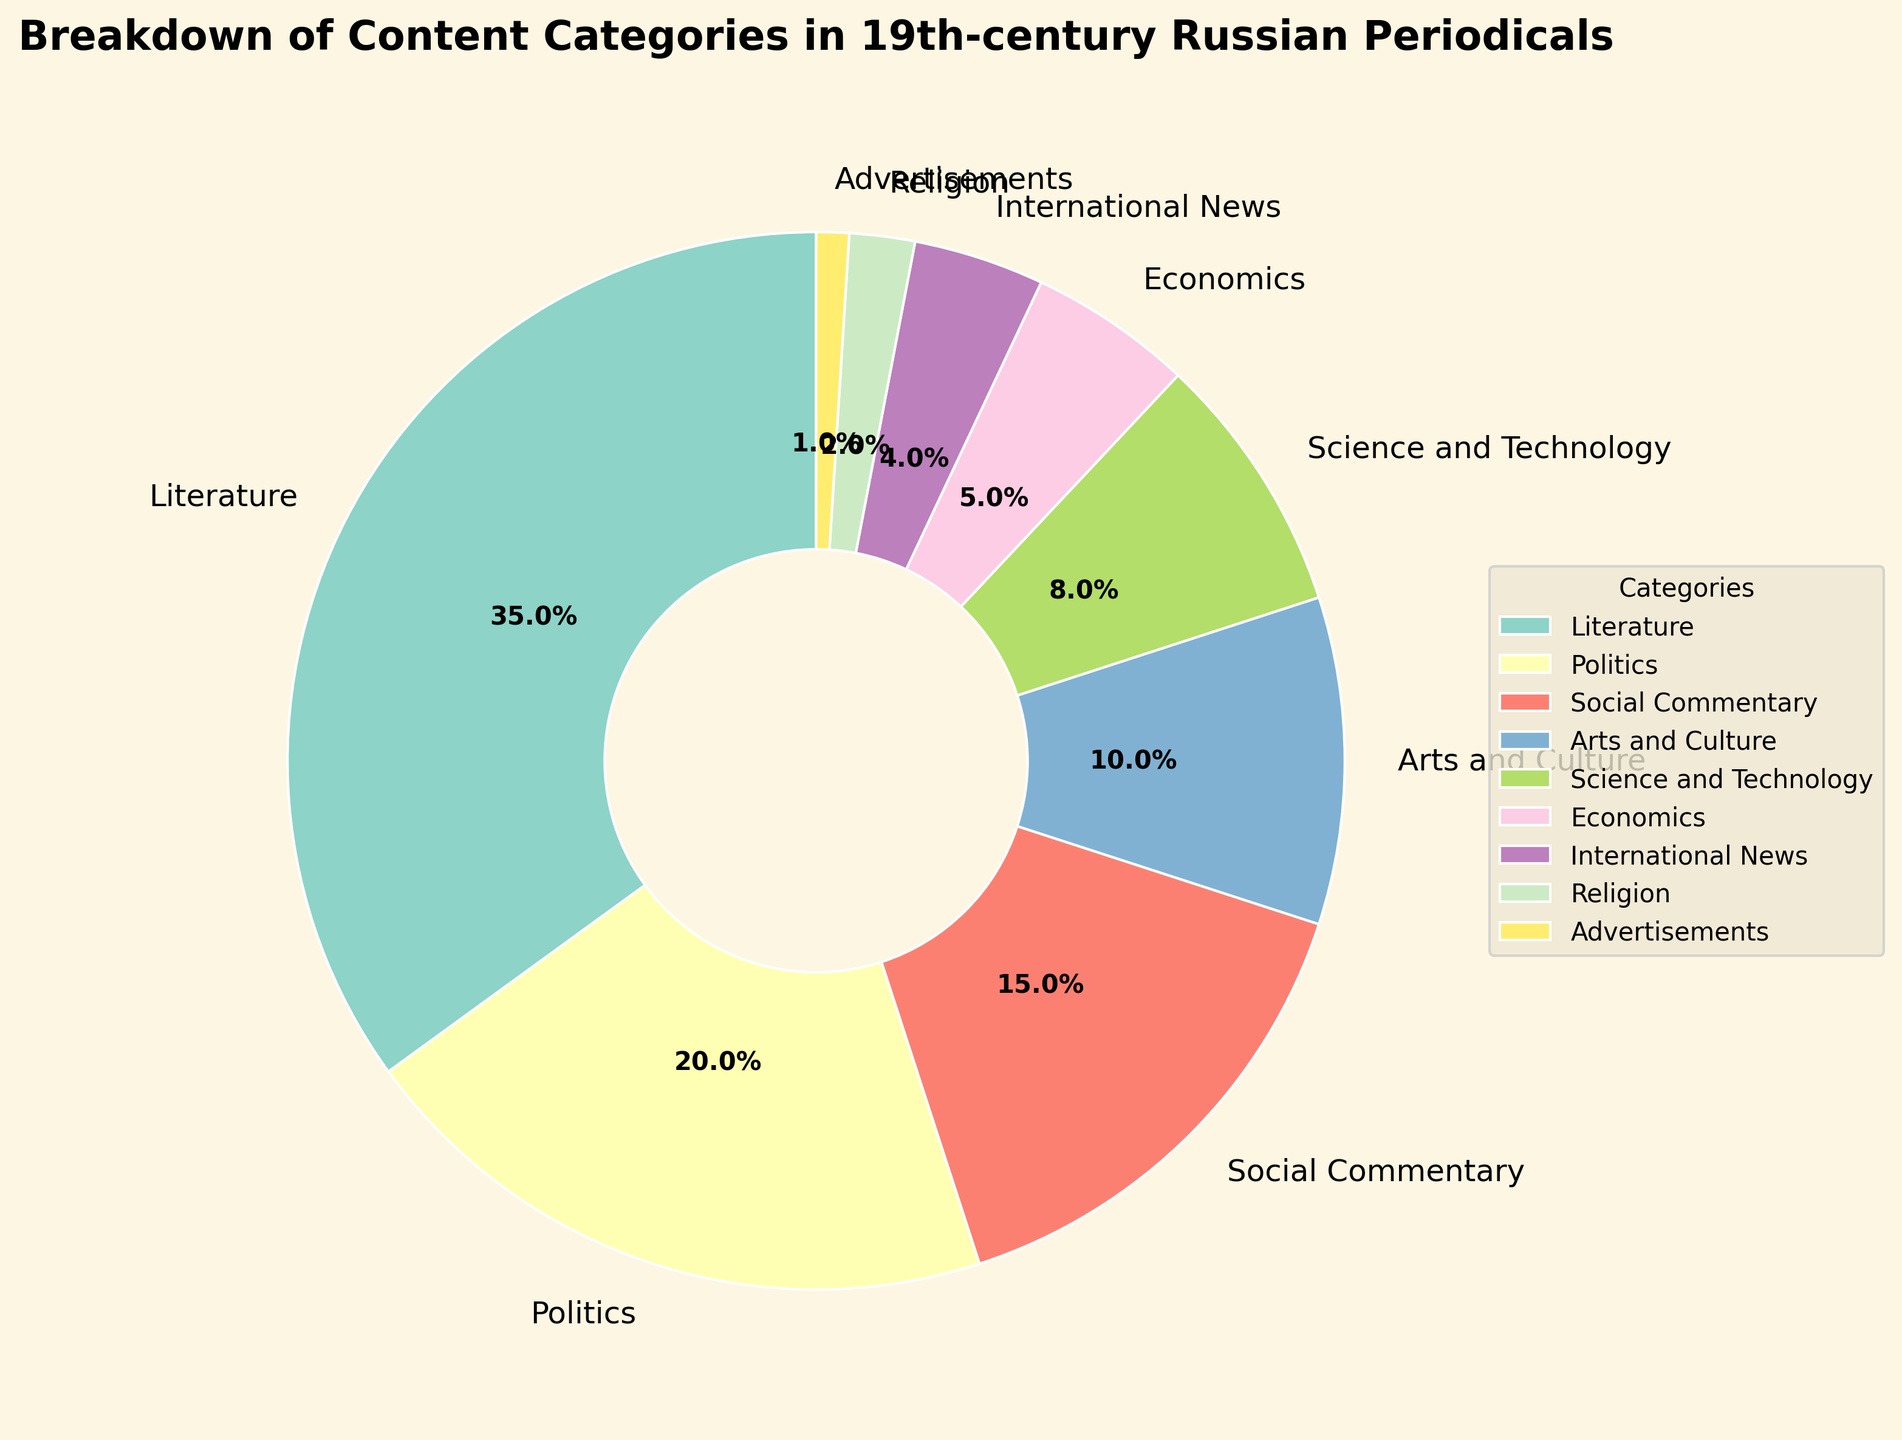Which content category occupies the largest percentage in 19th-century Russian periodicals? The figure shows a breakdown of content categories with their percentages. By checking which slice of the pie chart is largest, we find that Literature has the largest percentage at 35%.
Answer: Literature How much larger in percentage is the Literature category compared to the International News category? The percentage for Literature is 35%, and for International News, it is 4%. Subtracting the smaller percentage from the larger one (35% - 4% = 31%) shows that Literature is 31% larger than International News.
Answer: 31% What is the combined percentage of the Politics and Social Commentary categories? The figure shows Politics at 20% and Social Commentary at 15%. Adding these two percentages together (20% + 15%) gives the combined percentage of 35%.
Answer: 35% Which category has the smallest representation in the chart? By identifying the smallest slice, we can see that Advertisements have the smallest percentage at 1%.
Answer: Advertisements Is the percentage of Arts and Culture more than, less than, or equal to the combined percentage of Science and Technology and Religion? Arts and Culture is 10%. Science and Technology is 8%, and Religion is 2%. The combined percentage for Science and Technology and Religion is 10% (8% + 2%). Therefore, Arts and Culture is equal to the combined percentage of Science and Technology and Religion.
Answer: Equal Arrange the categories in decreasing order of their percentages. The percentages are given as follows: Literature (35%), Politics (20%), Social Commentary (15%), Arts and Culture (10%), Science and Technology (8%), Economics (5%), International News (4%), Religion (2%), Advertisements (1%). Arranging these in decreasing order: Literature, Politics, Social Commentary, Arts and Culture, Science and Technology, Economics, International News, Religion, Advertisements.
Answer: Literature, Politics, Social Commentary, Arts and Culture, Science and Technology, Economics, International News, Religion, Advertisements What is the total percentage of categories related to intellectual content (combining Literature, Politics, Social Commentary, Science and Technology, and Economics)? The percentages for intellectual content are Literature (35%), Politics (20%), Social Commentary (15%), Science and Technology (8%), and Economics (5%). Adding these together (35% + 20% + 15% + 8% + 5%) gives a total of 83%.
Answer: 83% 